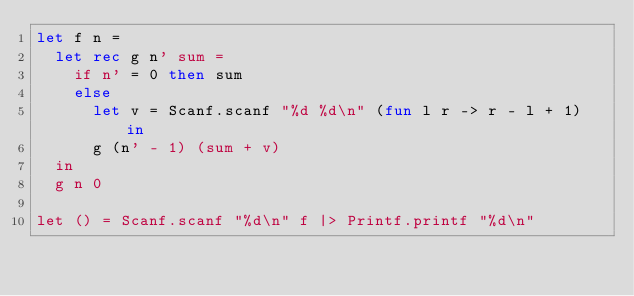<code> <loc_0><loc_0><loc_500><loc_500><_OCaml_>let f n =
  let rec g n' sum =
    if n' = 0 then sum
    else
      let v = Scanf.scanf "%d %d\n" (fun l r -> r - l + 1) in
      g (n' - 1) (sum + v)
  in
  g n 0

let () = Scanf.scanf "%d\n" f |> Printf.printf "%d\n"</code> 